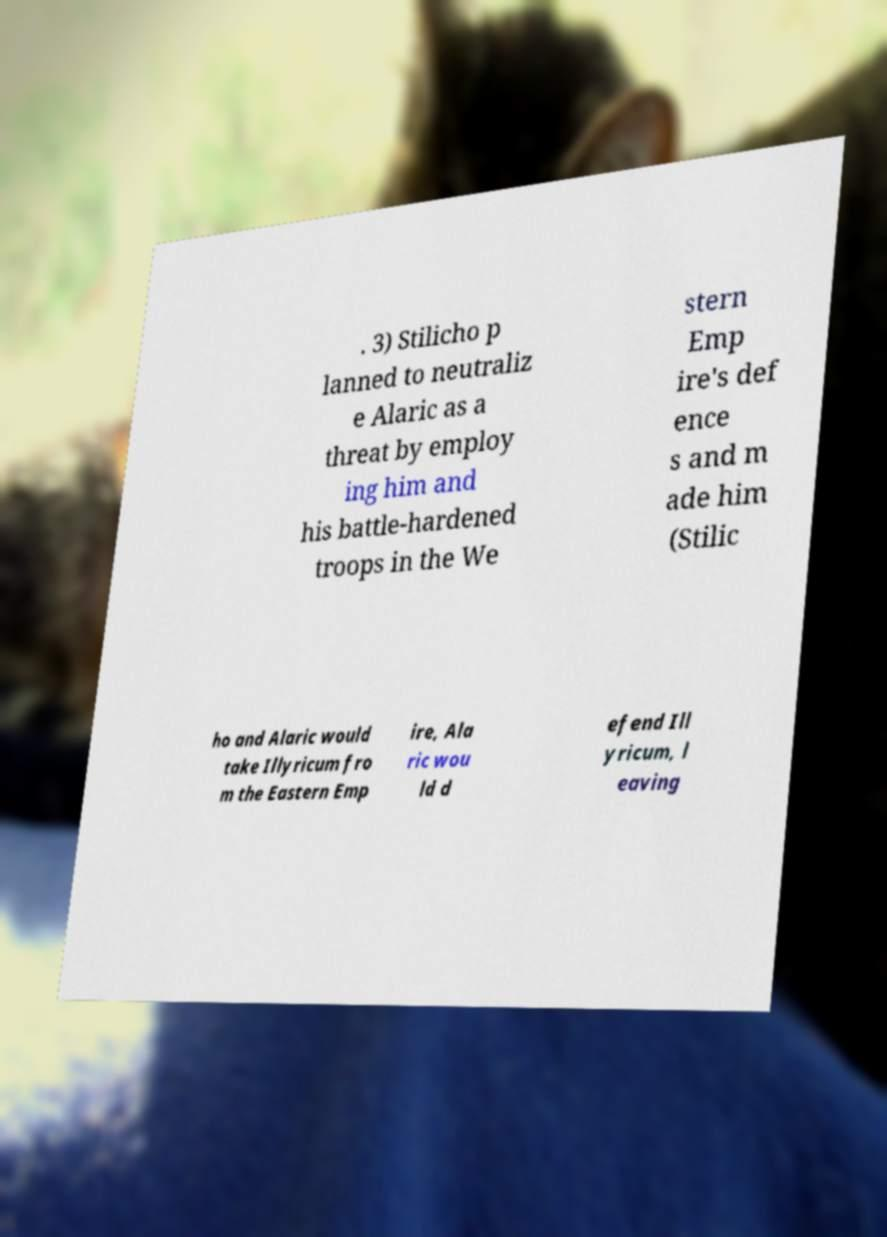Could you assist in decoding the text presented in this image and type it out clearly? . 3) Stilicho p lanned to neutraliz e Alaric as a threat by employ ing him and his battle-hardened troops in the We stern Emp ire's def ence s and m ade him (Stilic ho and Alaric would take Illyricum fro m the Eastern Emp ire, Ala ric wou ld d efend Ill yricum, l eaving 